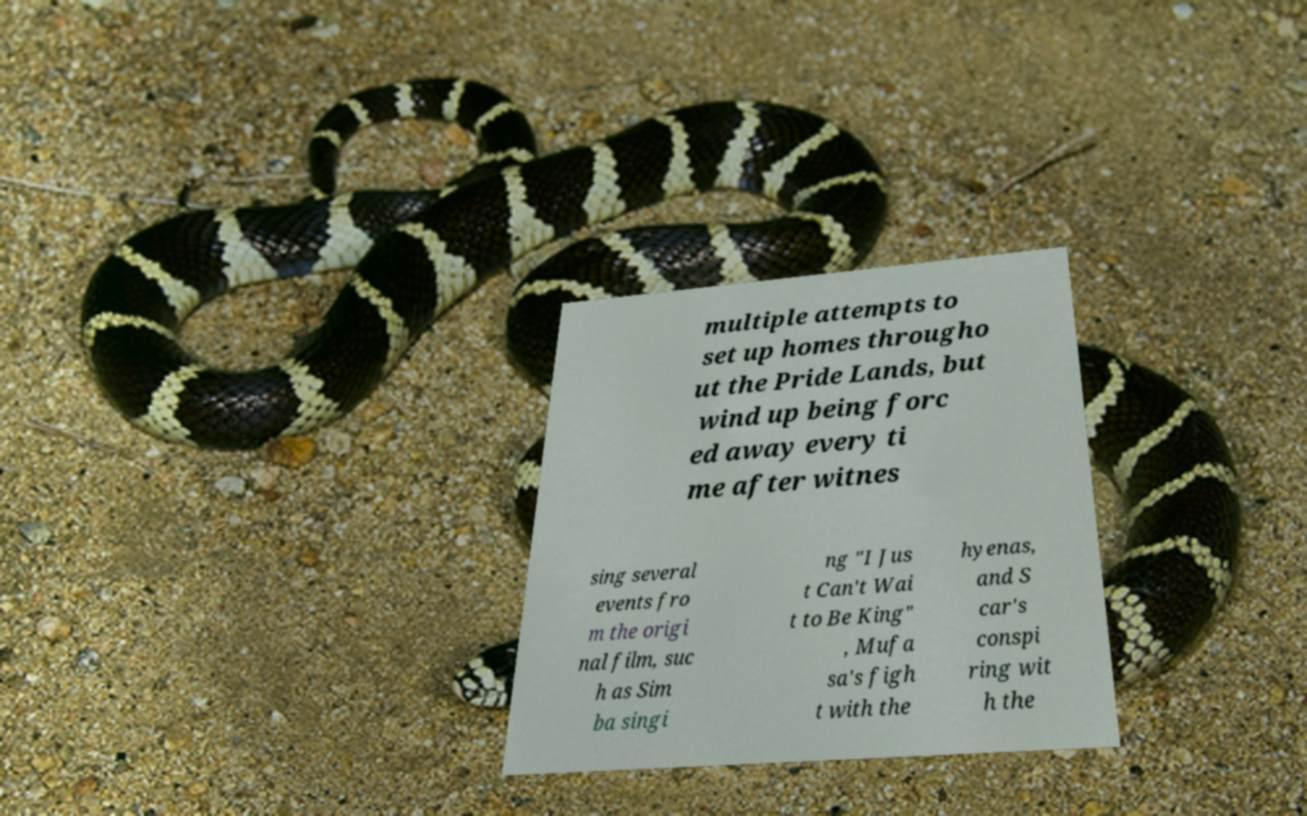For documentation purposes, I need the text within this image transcribed. Could you provide that? multiple attempts to set up homes througho ut the Pride Lands, but wind up being forc ed away every ti me after witnes sing several events fro m the origi nal film, suc h as Sim ba singi ng "I Jus t Can't Wai t to Be King" , Mufa sa's figh t with the hyenas, and S car's conspi ring wit h the 